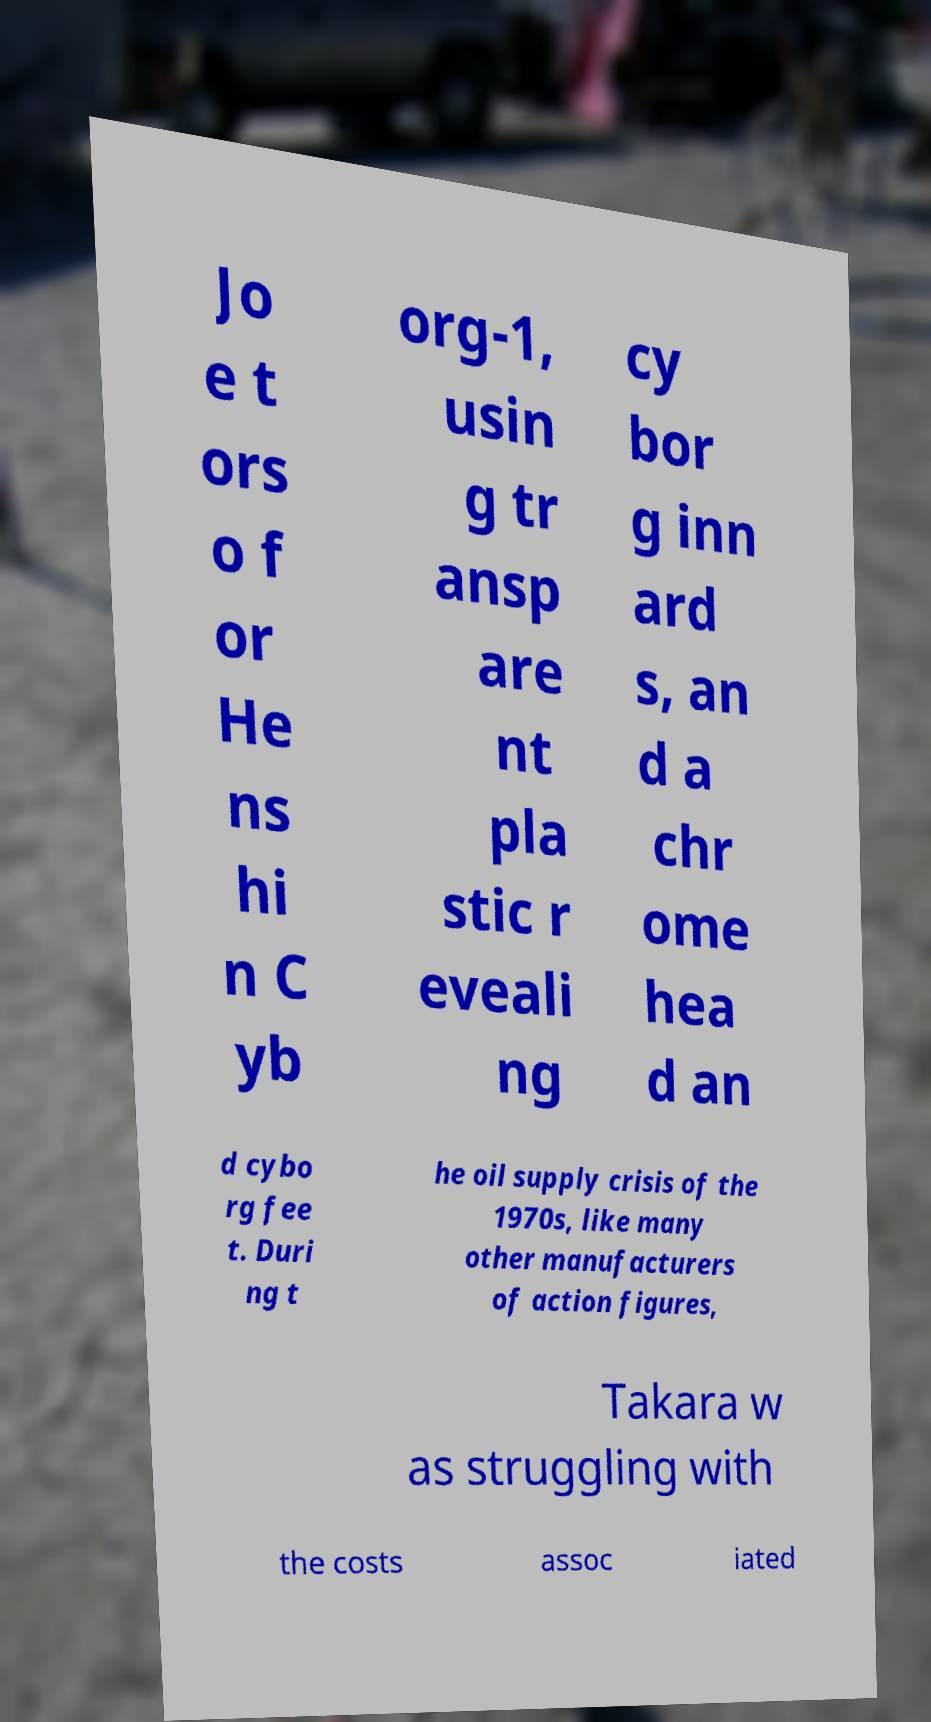Can you read and provide the text displayed in the image?This photo seems to have some interesting text. Can you extract and type it out for me? Jo e t ors o f or He ns hi n C yb org-1, usin g tr ansp are nt pla stic r eveali ng cy bor g inn ard s, an d a chr ome hea d an d cybo rg fee t. Duri ng t he oil supply crisis of the 1970s, like many other manufacturers of action figures, Takara w as struggling with the costs assoc iated 